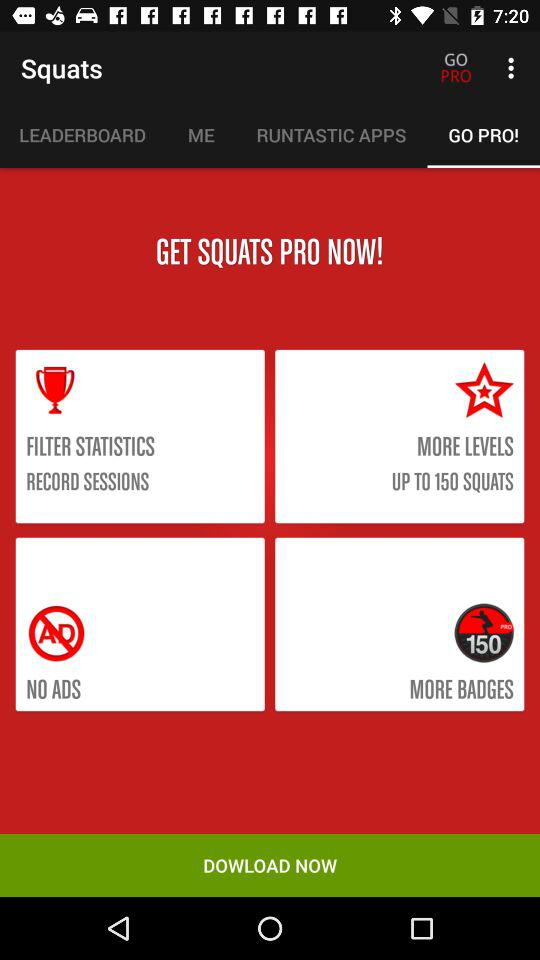What is the application name? The application name is "Squats". 